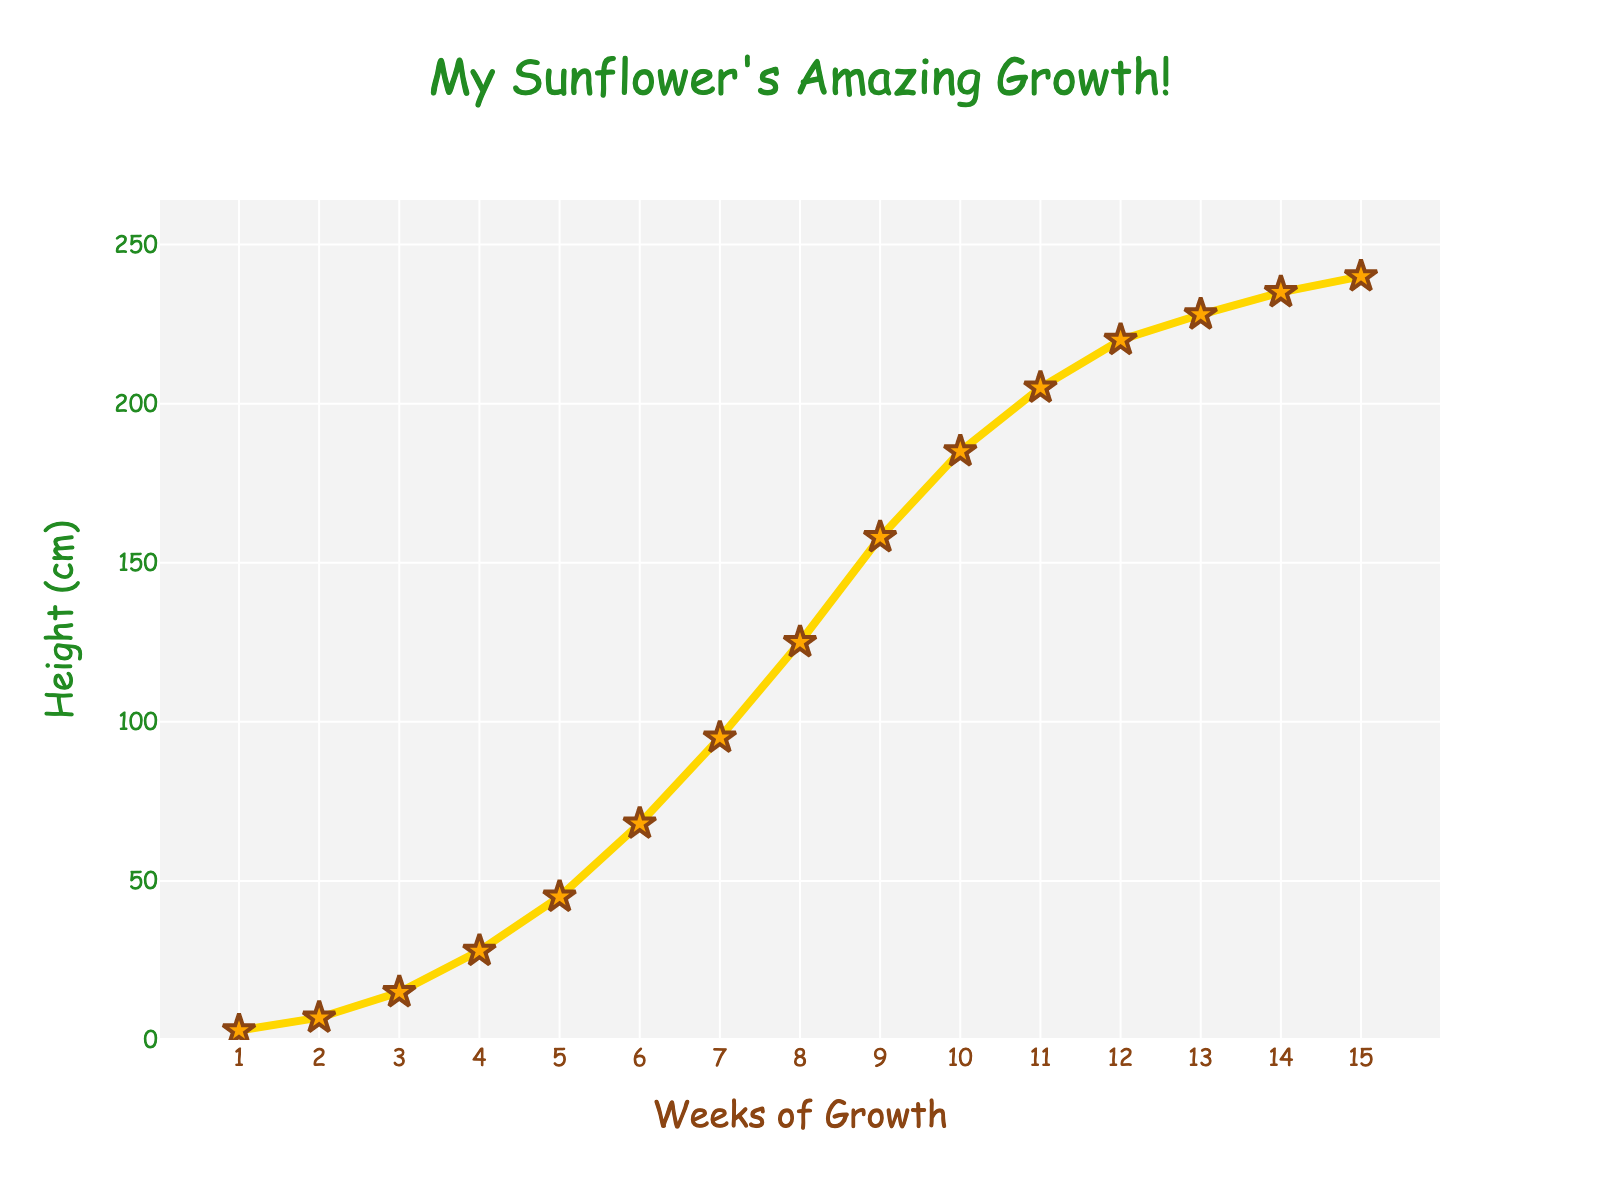What week did the sunflower grow the most in height? Look for the week-to-week increase in height. The highest increase is from week 6 to week 7, where the height increased from 68 cm to 95 cm, which is an increase of 27 cm.
Answer: Week 7 By how many centimeters did the sunflower grow from week 5 to week 10? Calculate the difference between the height at week 10 (185 cm) and week 5 (45 cm). 185 cm - 45 cm = 140 cm.
Answer: 140 cm How many weeks did it take for the sunflower to reach 100 cm? Identify the week where the sunflower height first equals or exceeds 100 cm. It reached 100 cm in week 8 when it grew to 125 cm.
Answer: 8 weeks Which week shows the smallest growth in height? Compare the week-to-week increases. The smallest growth is from week 14 to week 15, where the height grew from 235 cm to 240 cm, increasing by only 5 cm.
Answer: Week 15 What was the sunflower's height at the halfway point of the timeline (week 7.5)? Since the data is for each full week, take the average of week 7 and week 8. The height at week 7 is 95 cm, and at week 8 is 125 cm. (95 cm + 125 cm) / 2 = 110 cm.
Answer: 110 cm Compare the height growth from week 1 to week 5 with the growth from week 10 to week 15. Which period saw more growth? Calculate the growth for both periods. Week 1 to week 5: 45 cm - 3 cm = 42 cm. Week 10 to week 15: 240 cm - 185 cm = 55 cm. The growth from week 10 to week 15 was higher.
Answer: Week 10 to week 15 What is the average height of the sunflower over the 15 weeks? Sum all heights and divide by the number of weeks: (3 + 7 + 15 + 28 + 45 + 68 + 95 + 125 + 158 + 185 + 205 + 220 + 228 + 235 + 240) / 15 = 124.27 cm
Answer: 124.27 cm If the sunflower continues to grow at the average rate observed between weeks 13 and 15, what will be its height at week 16? Calculate the average growth from week 13 to week 15. (240 cm - 228 cm) / 2 weeks = 6 cm per week. Adding this to the height at week 15 (240 cm) gives 246 cm.
Answer: 246 cm Which week was the sunflower exactly half the final height? The final height at week 15 is 240 cm. Half is 120 cm. The sunflower reached and exceeded 120 cm at week 8 (125 cm). The closest before was week 7 at 95 cm.
Answer: Week 8 